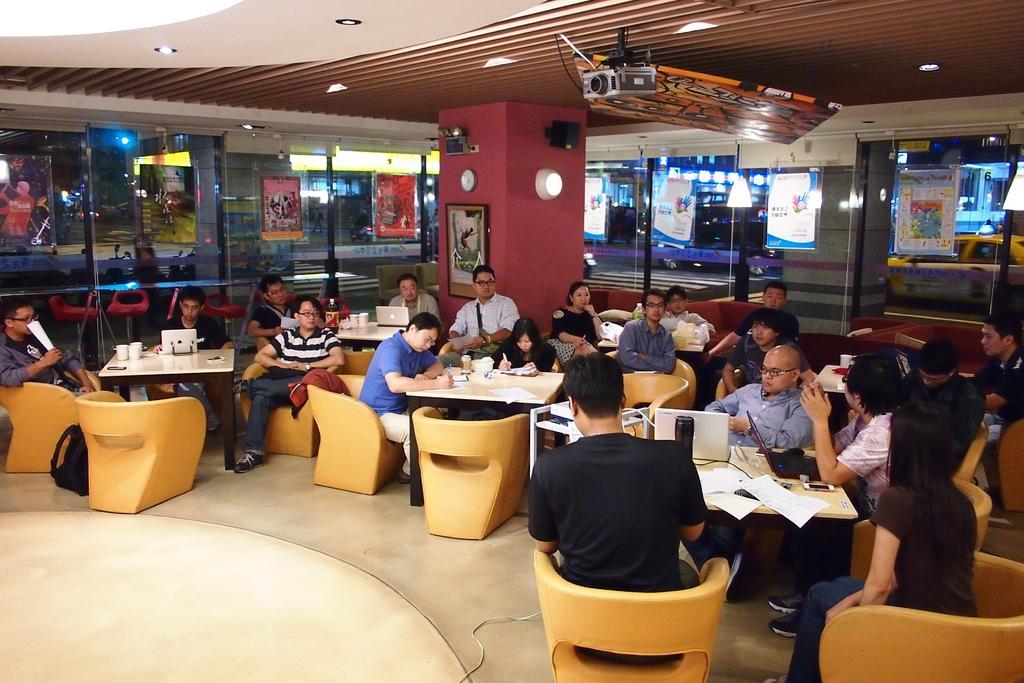Please provide a concise description of this image. Here we can see a group of people sitting on chairs with tables in front of them and some of them are having laptops in front of them and some of them are writing something on papers present in front of them 